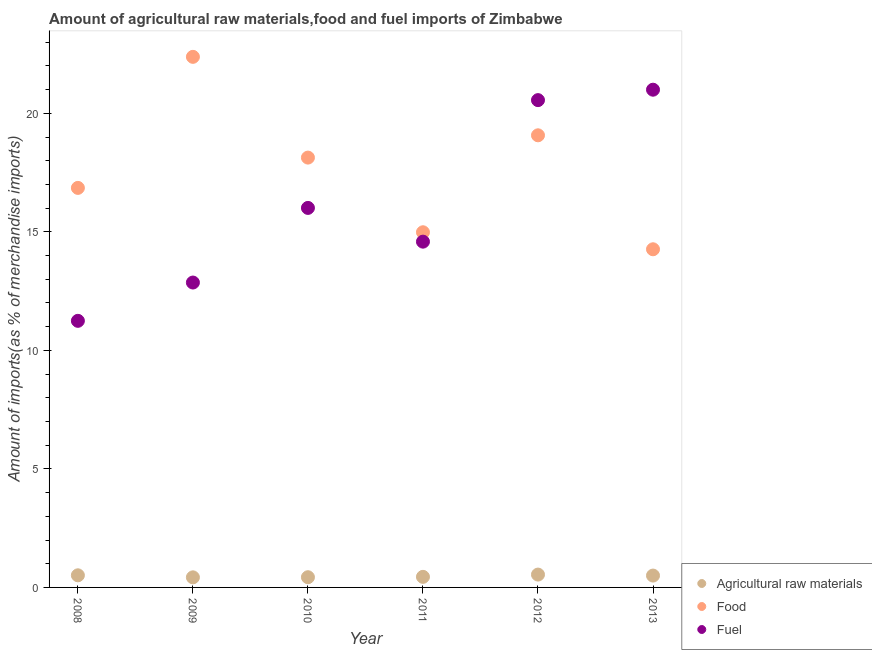How many different coloured dotlines are there?
Your answer should be compact. 3. Is the number of dotlines equal to the number of legend labels?
Ensure brevity in your answer.  Yes. What is the percentage of food imports in 2008?
Your answer should be very brief. 16.85. Across all years, what is the maximum percentage of raw materials imports?
Offer a very short reply. 0.54. Across all years, what is the minimum percentage of raw materials imports?
Provide a succinct answer. 0.43. In which year was the percentage of raw materials imports maximum?
Provide a succinct answer. 2012. In which year was the percentage of food imports minimum?
Your answer should be compact. 2013. What is the total percentage of food imports in the graph?
Provide a short and direct response. 105.69. What is the difference between the percentage of fuel imports in 2008 and that in 2011?
Ensure brevity in your answer.  -3.34. What is the difference between the percentage of fuel imports in 2010 and the percentage of food imports in 2012?
Offer a terse response. -3.06. What is the average percentage of fuel imports per year?
Make the answer very short. 16.04. In the year 2011, what is the difference between the percentage of food imports and percentage of raw materials imports?
Provide a succinct answer. 14.54. In how many years, is the percentage of raw materials imports greater than 3 %?
Offer a terse response. 0. What is the ratio of the percentage of raw materials imports in 2012 to that in 2013?
Make the answer very short. 1.08. What is the difference between the highest and the second highest percentage of fuel imports?
Make the answer very short. 0.44. What is the difference between the highest and the lowest percentage of fuel imports?
Offer a terse response. 9.75. In how many years, is the percentage of raw materials imports greater than the average percentage of raw materials imports taken over all years?
Offer a terse response. 3. Is it the case that in every year, the sum of the percentage of raw materials imports and percentage of food imports is greater than the percentage of fuel imports?
Give a very brief answer. No. Is the percentage of fuel imports strictly less than the percentage of raw materials imports over the years?
Give a very brief answer. No. How many years are there in the graph?
Provide a succinct answer. 6. How many legend labels are there?
Provide a short and direct response. 3. What is the title of the graph?
Offer a very short reply. Amount of agricultural raw materials,food and fuel imports of Zimbabwe. Does "Secondary" appear as one of the legend labels in the graph?
Ensure brevity in your answer.  No. What is the label or title of the Y-axis?
Ensure brevity in your answer.  Amount of imports(as % of merchandise imports). What is the Amount of imports(as % of merchandise imports) of Agricultural raw materials in 2008?
Provide a short and direct response. 0.51. What is the Amount of imports(as % of merchandise imports) in Food in 2008?
Provide a succinct answer. 16.85. What is the Amount of imports(as % of merchandise imports) in Fuel in 2008?
Provide a short and direct response. 11.25. What is the Amount of imports(as % of merchandise imports) of Agricultural raw materials in 2009?
Your response must be concise. 0.43. What is the Amount of imports(as % of merchandise imports) of Food in 2009?
Your response must be concise. 22.38. What is the Amount of imports(as % of merchandise imports) of Fuel in 2009?
Your answer should be compact. 12.86. What is the Amount of imports(as % of merchandise imports) of Agricultural raw materials in 2010?
Provide a short and direct response. 0.43. What is the Amount of imports(as % of merchandise imports) of Food in 2010?
Offer a very short reply. 18.13. What is the Amount of imports(as % of merchandise imports) of Fuel in 2010?
Make the answer very short. 16.01. What is the Amount of imports(as % of merchandise imports) in Agricultural raw materials in 2011?
Provide a short and direct response. 0.45. What is the Amount of imports(as % of merchandise imports) of Food in 2011?
Provide a short and direct response. 14.98. What is the Amount of imports(as % of merchandise imports) in Fuel in 2011?
Provide a short and direct response. 14.59. What is the Amount of imports(as % of merchandise imports) in Agricultural raw materials in 2012?
Provide a succinct answer. 0.54. What is the Amount of imports(as % of merchandise imports) of Food in 2012?
Make the answer very short. 19.07. What is the Amount of imports(as % of merchandise imports) of Fuel in 2012?
Provide a succinct answer. 20.56. What is the Amount of imports(as % of merchandise imports) in Agricultural raw materials in 2013?
Your response must be concise. 0.5. What is the Amount of imports(as % of merchandise imports) in Food in 2013?
Keep it short and to the point. 14.26. What is the Amount of imports(as % of merchandise imports) in Fuel in 2013?
Provide a short and direct response. 21. Across all years, what is the maximum Amount of imports(as % of merchandise imports) in Agricultural raw materials?
Your answer should be compact. 0.54. Across all years, what is the maximum Amount of imports(as % of merchandise imports) of Food?
Provide a short and direct response. 22.38. Across all years, what is the maximum Amount of imports(as % of merchandise imports) of Fuel?
Give a very brief answer. 21. Across all years, what is the minimum Amount of imports(as % of merchandise imports) of Agricultural raw materials?
Provide a short and direct response. 0.43. Across all years, what is the minimum Amount of imports(as % of merchandise imports) in Food?
Provide a succinct answer. 14.26. Across all years, what is the minimum Amount of imports(as % of merchandise imports) in Fuel?
Offer a very short reply. 11.25. What is the total Amount of imports(as % of merchandise imports) in Agricultural raw materials in the graph?
Provide a short and direct response. 2.85. What is the total Amount of imports(as % of merchandise imports) of Food in the graph?
Provide a short and direct response. 105.69. What is the total Amount of imports(as % of merchandise imports) of Fuel in the graph?
Give a very brief answer. 96.26. What is the difference between the Amount of imports(as % of merchandise imports) of Agricultural raw materials in 2008 and that in 2009?
Your answer should be compact. 0.09. What is the difference between the Amount of imports(as % of merchandise imports) of Food in 2008 and that in 2009?
Give a very brief answer. -5.53. What is the difference between the Amount of imports(as % of merchandise imports) of Fuel in 2008 and that in 2009?
Give a very brief answer. -1.62. What is the difference between the Amount of imports(as % of merchandise imports) in Agricultural raw materials in 2008 and that in 2010?
Keep it short and to the point. 0.08. What is the difference between the Amount of imports(as % of merchandise imports) in Food in 2008 and that in 2010?
Provide a succinct answer. -1.28. What is the difference between the Amount of imports(as % of merchandise imports) in Fuel in 2008 and that in 2010?
Keep it short and to the point. -4.76. What is the difference between the Amount of imports(as % of merchandise imports) of Agricultural raw materials in 2008 and that in 2011?
Provide a short and direct response. 0.07. What is the difference between the Amount of imports(as % of merchandise imports) in Food in 2008 and that in 2011?
Ensure brevity in your answer.  1.87. What is the difference between the Amount of imports(as % of merchandise imports) of Fuel in 2008 and that in 2011?
Provide a short and direct response. -3.34. What is the difference between the Amount of imports(as % of merchandise imports) in Agricultural raw materials in 2008 and that in 2012?
Offer a terse response. -0.03. What is the difference between the Amount of imports(as % of merchandise imports) in Food in 2008 and that in 2012?
Provide a short and direct response. -2.22. What is the difference between the Amount of imports(as % of merchandise imports) of Fuel in 2008 and that in 2012?
Provide a short and direct response. -9.31. What is the difference between the Amount of imports(as % of merchandise imports) in Agricultural raw materials in 2008 and that in 2013?
Give a very brief answer. 0.01. What is the difference between the Amount of imports(as % of merchandise imports) in Food in 2008 and that in 2013?
Keep it short and to the point. 2.59. What is the difference between the Amount of imports(as % of merchandise imports) in Fuel in 2008 and that in 2013?
Keep it short and to the point. -9.75. What is the difference between the Amount of imports(as % of merchandise imports) in Agricultural raw materials in 2009 and that in 2010?
Provide a short and direct response. -0.01. What is the difference between the Amount of imports(as % of merchandise imports) of Food in 2009 and that in 2010?
Provide a short and direct response. 4.25. What is the difference between the Amount of imports(as % of merchandise imports) in Fuel in 2009 and that in 2010?
Provide a short and direct response. -3.15. What is the difference between the Amount of imports(as % of merchandise imports) in Agricultural raw materials in 2009 and that in 2011?
Your response must be concise. -0.02. What is the difference between the Amount of imports(as % of merchandise imports) in Food in 2009 and that in 2011?
Make the answer very short. 7.4. What is the difference between the Amount of imports(as % of merchandise imports) in Fuel in 2009 and that in 2011?
Your answer should be compact. -1.72. What is the difference between the Amount of imports(as % of merchandise imports) of Agricultural raw materials in 2009 and that in 2012?
Provide a succinct answer. -0.12. What is the difference between the Amount of imports(as % of merchandise imports) in Food in 2009 and that in 2012?
Your answer should be compact. 3.31. What is the difference between the Amount of imports(as % of merchandise imports) of Fuel in 2009 and that in 2012?
Offer a very short reply. -7.69. What is the difference between the Amount of imports(as % of merchandise imports) of Agricultural raw materials in 2009 and that in 2013?
Provide a short and direct response. -0.07. What is the difference between the Amount of imports(as % of merchandise imports) in Food in 2009 and that in 2013?
Keep it short and to the point. 8.12. What is the difference between the Amount of imports(as % of merchandise imports) of Fuel in 2009 and that in 2013?
Give a very brief answer. -8.13. What is the difference between the Amount of imports(as % of merchandise imports) of Agricultural raw materials in 2010 and that in 2011?
Provide a succinct answer. -0.02. What is the difference between the Amount of imports(as % of merchandise imports) in Food in 2010 and that in 2011?
Keep it short and to the point. 3.15. What is the difference between the Amount of imports(as % of merchandise imports) of Fuel in 2010 and that in 2011?
Provide a short and direct response. 1.42. What is the difference between the Amount of imports(as % of merchandise imports) of Agricultural raw materials in 2010 and that in 2012?
Make the answer very short. -0.11. What is the difference between the Amount of imports(as % of merchandise imports) in Food in 2010 and that in 2012?
Your answer should be very brief. -0.94. What is the difference between the Amount of imports(as % of merchandise imports) in Fuel in 2010 and that in 2012?
Your response must be concise. -4.55. What is the difference between the Amount of imports(as % of merchandise imports) of Agricultural raw materials in 2010 and that in 2013?
Offer a terse response. -0.07. What is the difference between the Amount of imports(as % of merchandise imports) in Food in 2010 and that in 2013?
Ensure brevity in your answer.  3.87. What is the difference between the Amount of imports(as % of merchandise imports) in Fuel in 2010 and that in 2013?
Your response must be concise. -4.99. What is the difference between the Amount of imports(as % of merchandise imports) in Agricultural raw materials in 2011 and that in 2012?
Provide a succinct answer. -0.1. What is the difference between the Amount of imports(as % of merchandise imports) in Food in 2011 and that in 2012?
Provide a short and direct response. -4.09. What is the difference between the Amount of imports(as % of merchandise imports) of Fuel in 2011 and that in 2012?
Provide a succinct answer. -5.97. What is the difference between the Amount of imports(as % of merchandise imports) in Agricultural raw materials in 2011 and that in 2013?
Keep it short and to the point. -0.05. What is the difference between the Amount of imports(as % of merchandise imports) in Food in 2011 and that in 2013?
Provide a succinct answer. 0.72. What is the difference between the Amount of imports(as % of merchandise imports) of Fuel in 2011 and that in 2013?
Your response must be concise. -6.41. What is the difference between the Amount of imports(as % of merchandise imports) in Agricultural raw materials in 2012 and that in 2013?
Ensure brevity in your answer.  0.04. What is the difference between the Amount of imports(as % of merchandise imports) in Food in 2012 and that in 2013?
Provide a succinct answer. 4.81. What is the difference between the Amount of imports(as % of merchandise imports) of Fuel in 2012 and that in 2013?
Provide a short and direct response. -0.44. What is the difference between the Amount of imports(as % of merchandise imports) of Agricultural raw materials in 2008 and the Amount of imports(as % of merchandise imports) of Food in 2009?
Provide a succinct answer. -21.87. What is the difference between the Amount of imports(as % of merchandise imports) in Agricultural raw materials in 2008 and the Amount of imports(as % of merchandise imports) in Fuel in 2009?
Ensure brevity in your answer.  -12.35. What is the difference between the Amount of imports(as % of merchandise imports) in Food in 2008 and the Amount of imports(as % of merchandise imports) in Fuel in 2009?
Your response must be concise. 3.99. What is the difference between the Amount of imports(as % of merchandise imports) in Agricultural raw materials in 2008 and the Amount of imports(as % of merchandise imports) in Food in 2010?
Your response must be concise. -17.62. What is the difference between the Amount of imports(as % of merchandise imports) of Agricultural raw materials in 2008 and the Amount of imports(as % of merchandise imports) of Fuel in 2010?
Offer a very short reply. -15.5. What is the difference between the Amount of imports(as % of merchandise imports) of Food in 2008 and the Amount of imports(as % of merchandise imports) of Fuel in 2010?
Your answer should be compact. 0.84. What is the difference between the Amount of imports(as % of merchandise imports) of Agricultural raw materials in 2008 and the Amount of imports(as % of merchandise imports) of Food in 2011?
Keep it short and to the point. -14.47. What is the difference between the Amount of imports(as % of merchandise imports) in Agricultural raw materials in 2008 and the Amount of imports(as % of merchandise imports) in Fuel in 2011?
Your answer should be very brief. -14.07. What is the difference between the Amount of imports(as % of merchandise imports) of Food in 2008 and the Amount of imports(as % of merchandise imports) of Fuel in 2011?
Give a very brief answer. 2.27. What is the difference between the Amount of imports(as % of merchandise imports) in Agricultural raw materials in 2008 and the Amount of imports(as % of merchandise imports) in Food in 2012?
Make the answer very short. -18.56. What is the difference between the Amount of imports(as % of merchandise imports) of Agricultural raw materials in 2008 and the Amount of imports(as % of merchandise imports) of Fuel in 2012?
Provide a succinct answer. -20.05. What is the difference between the Amount of imports(as % of merchandise imports) in Food in 2008 and the Amount of imports(as % of merchandise imports) in Fuel in 2012?
Your answer should be very brief. -3.7. What is the difference between the Amount of imports(as % of merchandise imports) in Agricultural raw materials in 2008 and the Amount of imports(as % of merchandise imports) in Food in 2013?
Offer a very short reply. -13.75. What is the difference between the Amount of imports(as % of merchandise imports) in Agricultural raw materials in 2008 and the Amount of imports(as % of merchandise imports) in Fuel in 2013?
Provide a short and direct response. -20.48. What is the difference between the Amount of imports(as % of merchandise imports) of Food in 2008 and the Amount of imports(as % of merchandise imports) of Fuel in 2013?
Make the answer very short. -4.14. What is the difference between the Amount of imports(as % of merchandise imports) in Agricultural raw materials in 2009 and the Amount of imports(as % of merchandise imports) in Food in 2010?
Provide a succinct answer. -17.71. What is the difference between the Amount of imports(as % of merchandise imports) in Agricultural raw materials in 2009 and the Amount of imports(as % of merchandise imports) in Fuel in 2010?
Ensure brevity in your answer.  -15.58. What is the difference between the Amount of imports(as % of merchandise imports) in Food in 2009 and the Amount of imports(as % of merchandise imports) in Fuel in 2010?
Make the answer very short. 6.37. What is the difference between the Amount of imports(as % of merchandise imports) in Agricultural raw materials in 2009 and the Amount of imports(as % of merchandise imports) in Food in 2011?
Provide a short and direct response. -14.56. What is the difference between the Amount of imports(as % of merchandise imports) of Agricultural raw materials in 2009 and the Amount of imports(as % of merchandise imports) of Fuel in 2011?
Make the answer very short. -14.16. What is the difference between the Amount of imports(as % of merchandise imports) in Food in 2009 and the Amount of imports(as % of merchandise imports) in Fuel in 2011?
Make the answer very short. 7.8. What is the difference between the Amount of imports(as % of merchandise imports) in Agricultural raw materials in 2009 and the Amount of imports(as % of merchandise imports) in Food in 2012?
Offer a very short reply. -18.65. What is the difference between the Amount of imports(as % of merchandise imports) of Agricultural raw materials in 2009 and the Amount of imports(as % of merchandise imports) of Fuel in 2012?
Keep it short and to the point. -20.13. What is the difference between the Amount of imports(as % of merchandise imports) in Food in 2009 and the Amount of imports(as % of merchandise imports) in Fuel in 2012?
Give a very brief answer. 1.83. What is the difference between the Amount of imports(as % of merchandise imports) in Agricultural raw materials in 2009 and the Amount of imports(as % of merchandise imports) in Food in 2013?
Your answer should be very brief. -13.84. What is the difference between the Amount of imports(as % of merchandise imports) in Agricultural raw materials in 2009 and the Amount of imports(as % of merchandise imports) in Fuel in 2013?
Give a very brief answer. -20.57. What is the difference between the Amount of imports(as % of merchandise imports) in Food in 2009 and the Amount of imports(as % of merchandise imports) in Fuel in 2013?
Provide a short and direct response. 1.39. What is the difference between the Amount of imports(as % of merchandise imports) in Agricultural raw materials in 2010 and the Amount of imports(as % of merchandise imports) in Food in 2011?
Make the answer very short. -14.55. What is the difference between the Amount of imports(as % of merchandise imports) in Agricultural raw materials in 2010 and the Amount of imports(as % of merchandise imports) in Fuel in 2011?
Your response must be concise. -14.16. What is the difference between the Amount of imports(as % of merchandise imports) in Food in 2010 and the Amount of imports(as % of merchandise imports) in Fuel in 2011?
Keep it short and to the point. 3.55. What is the difference between the Amount of imports(as % of merchandise imports) in Agricultural raw materials in 2010 and the Amount of imports(as % of merchandise imports) in Food in 2012?
Ensure brevity in your answer.  -18.64. What is the difference between the Amount of imports(as % of merchandise imports) in Agricultural raw materials in 2010 and the Amount of imports(as % of merchandise imports) in Fuel in 2012?
Provide a succinct answer. -20.13. What is the difference between the Amount of imports(as % of merchandise imports) of Food in 2010 and the Amount of imports(as % of merchandise imports) of Fuel in 2012?
Your answer should be very brief. -2.42. What is the difference between the Amount of imports(as % of merchandise imports) of Agricultural raw materials in 2010 and the Amount of imports(as % of merchandise imports) of Food in 2013?
Make the answer very short. -13.83. What is the difference between the Amount of imports(as % of merchandise imports) of Agricultural raw materials in 2010 and the Amount of imports(as % of merchandise imports) of Fuel in 2013?
Offer a terse response. -20.57. What is the difference between the Amount of imports(as % of merchandise imports) of Food in 2010 and the Amount of imports(as % of merchandise imports) of Fuel in 2013?
Offer a very short reply. -2.86. What is the difference between the Amount of imports(as % of merchandise imports) of Agricultural raw materials in 2011 and the Amount of imports(as % of merchandise imports) of Food in 2012?
Your answer should be compact. -18.63. What is the difference between the Amount of imports(as % of merchandise imports) of Agricultural raw materials in 2011 and the Amount of imports(as % of merchandise imports) of Fuel in 2012?
Your answer should be compact. -20.11. What is the difference between the Amount of imports(as % of merchandise imports) of Food in 2011 and the Amount of imports(as % of merchandise imports) of Fuel in 2012?
Your answer should be compact. -5.57. What is the difference between the Amount of imports(as % of merchandise imports) of Agricultural raw materials in 2011 and the Amount of imports(as % of merchandise imports) of Food in 2013?
Provide a succinct answer. -13.82. What is the difference between the Amount of imports(as % of merchandise imports) in Agricultural raw materials in 2011 and the Amount of imports(as % of merchandise imports) in Fuel in 2013?
Provide a succinct answer. -20.55. What is the difference between the Amount of imports(as % of merchandise imports) in Food in 2011 and the Amount of imports(as % of merchandise imports) in Fuel in 2013?
Your answer should be compact. -6.01. What is the difference between the Amount of imports(as % of merchandise imports) of Agricultural raw materials in 2012 and the Amount of imports(as % of merchandise imports) of Food in 2013?
Your answer should be very brief. -13.72. What is the difference between the Amount of imports(as % of merchandise imports) of Agricultural raw materials in 2012 and the Amount of imports(as % of merchandise imports) of Fuel in 2013?
Your response must be concise. -20.45. What is the difference between the Amount of imports(as % of merchandise imports) of Food in 2012 and the Amount of imports(as % of merchandise imports) of Fuel in 2013?
Your answer should be very brief. -1.92. What is the average Amount of imports(as % of merchandise imports) of Agricultural raw materials per year?
Your answer should be compact. 0.48. What is the average Amount of imports(as % of merchandise imports) in Food per year?
Provide a short and direct response. 17.61. What is the average Amount of imports(as % of merchandise imports) in Fuel per year?
Give a very brief answer. 16.04. In the year 2008, what is the difference between the Amount of imports(as % of merchandise imports) of Agricultural raw materials and Amount of imports(as % of merchandise imports) of Food?
Your answer should be very brief. -16.34. In the year 2008, what is the difference between the Amount of imports(as % of merchandise imports) of Agricultural raw materials and Amount of imports(as % of merchandise imports) of Fuel?
Provide a short and direct response. -10.73. In the year 2008, what is the difference between the Amount of imports(as % of merchandise imports) in Food and Amount of imports(as % of merchandise imports) in Fuel?
Offer a terse response. 5.61. In the year 2009, what is the difference between the Amount of imports(as % of merchandise imports) in Agricultural raw materials and Amount of imports(as % of merchandise imports) in Food?
Provide a succinct answer. -21.96. In the year 2009, what is the difference between the Amount of imports(as % of merchandise imports) in Agricultural raw materials and Amount of imports(as % of merchandise imports) in Fuel?
Your answer should be compact. -12.44. In the year 2009, what is the difference between the Amount of imports(as % of merchandise imports) in Food and Amount of imports(as % of merchandise imports) in Fuel?
Provide a succinct answer. 9.52. In the year 2010, what is the difference between the Amount of imports(as % of merchandise imports) of Agricultural raw materials and Amount of imports(as % of merchandise imports) of Food?
Your answer should be very brief. -17.7. In the year 2010, what is the difference between the Amount of imports(as % of merchandise imports) in Agricultural raw materials and Amount of imports(as % of merchandise imports) in Fuel?
Your response must be concise. -15.58. In the year 2010, what is the difference between the Amount of imports(as % of merchandise imports) of Food and Amount of imports(as % of merchandise imports) of Fuel?
Your answer should be very brief. 2.12. In the year 2011, what is the difference between the Amount of imports(as % of merchandise imports) of Agricultural raw materials and Amount of imports(as % of merchandise imports) of Food?
Ensure brevity in your answer.  -14.54. In the year 2011, what is the difference between the Amount of imports(as % of merchandise imports) in Agricultural raw materials and Amount of imports(as % of merchandise imports) in Fuel?
Provide a short and direct response. -14.14. In the year 2011, what is the difference between the Amount of imports(as % of merchandise imports) of Food and Amount of imports(as % of merchandise imports) of Fuel?
Ensure brevity in your answer.  0.4. In the year 2012, what is the difference between the Amount of imports(as % of merchandise imports) of Agricultural raw materials and Amount of imports(as % of merchandise imports) of Food?
Provide a succinct answer. -18.53. In the year 2012, what is the difference between the Amount of imports(as % of merchandise imports) of Agricultural raw materials and Amount of imports(as % of merchandise imports) of Fuel?
Give a very brief answer. -20.01. In the year 2012, what is the difference between the Amount of imports(as % of merchandise imports) of Food and Amount of imports(as % of merchandise imports) of Fuel?
Provide a short and direct response. -1.48. In the year 2013, what is the difference between the Amount of imports(as % of merchandise imports) of Agricultural raw materials and Amount of imports(as % of merchandise imports) of Food?
Your answer should be very brief. -13.76. In the year 2013, what is the difference between the Amount of imports(as % of merchandise imports) in Agricultural raw materials and Amount of imports(as % of merchandise imports) in Fuel?
Your response must be concise. -20.5. In the year 2013, what is the difference between the Amount of imports(as % of merchandise imports) in Food and Amount of imports(as % of merchandise imports) in Fuel?
Keep it short and to the point. -6.73. What is the ratio of the Amount of imports(as % of merchandise imports) of Agricultural raw materials in 2008 to that in 2009?
Your answer should be very brief. 1.2. What is the ratio of the Amount of imports(as % of merchandise imports) of Food in 2008 to that in 2009?
Your answer should be very brief. 0.75. What is the ratio of the Amount of imports(as % of merchandise imports) in Fuel in 2008 to that in 2009?
Provide a short and direct response. 0.87. What is the ratio of the Amount of imports(as % of merchandise imports) in Agricultural raw materials in 2008 to that in 2010?
Provide a short and direct response. 1.19. What is the ratio of the Amount of imports(as % of merchandise imports) of Food in 2008 to that in 2010?
Offer a terse response. 0.93. What is the ratio of the Amount of imports(as % of merchandise imports) in Fuel in 2008 to that in 2010?
Your answer should be compact. 0.7. What is the ratio of the Amount of imports(as % of merchandise imports) of Agricultural raw materials in 2008 to that in 2011?
Your response must be concise. 1.15. What is the ratio of the Amount of imports(as % of merchandise imports) of Food in 2008 to that in 2011?
Offer a terse response. 1.12. What is the ratio of the Amount of imports(as % of merchandise imports) of Fuel in 2008 to that in 2011?
Offer a terse response. 0.77. What is the ratio of the Amount of imports(as % of merchandise imports) in Agricultural raw materials in 2008 to that in 2012?
Keep it short and to the point. 0.94. What is the ratio of the Amount of imports(as % of merchandise imports) in Food in 2008 to that in 2012?
Your response must be concise. 0.88. What is the ratio of the Amount of imports(as % of merchandise imports) of Fuel in 2008 to that in 2012?
Offer a terse response. 0.55. What is the ratio of the Amount of imports(as % of merchandise imports) in Food in 2008 to that in 2013?
Your answer should be very brief. 1.18. What is the ratio of the Amount of imports(as % of merchandise imports) in Fuel in 2008 to that in 2013?
Offer a very short reply. 0.54. What is the ratio of the Amount of imports(as % of merchandise imports) in Agricultural raw materials in 2009 to that in 2010?
Your response must be concise. 0.99. What is the ratio of the Amount of imports(as % of merchandise imports) in Food in 2009 to that in 2010?
Offer a terse response. 1.23. What is the ratio of the Amount of imports(as % of merchandise imports) of Fuel in 2009 to that in 2010?
Your response must be concise. 0.8. What is the ratio of the Amount of imports(as % of merchandise imports) of Agricultural raw materials in 2009 to that in 2011?
Provide a succinct answer. 0.95. What is the ratio of the Amount of imports(as % of merchandise imports) in Food in 2009 to that in 2011?
Offer a very short reply. 1.49. What is the ratio of the Amount of imports(as % of merchandise imports) in Fuel in 2009 to that in 2011?
Keep it short and to the point. 0.88. What is the ratio of the Amount of imports(as % of merchandise imports) of Agricultural raw materials in 2009 to that in 2012?
Provide a succinct answer. 0.79. What is the ratio of the Amount of imports(as % of merchandise imports) in Food in 2009 to that in 2012?
Keep it short and to the point. 1.17. What is the ratio of the Amount of imports(as % of merchandise imports) in Fuel in 2009 to that in 2012?
Make the answer very short. 0.63. What is the ratio of the Amount of imports(as % of merchandise imports) in Agricultural raw materials in 2009 to that in 2013?
Provide a short and direct response. 0.85. What is the ratio of the Amount of imports(as % of merchandise imports) in Food in 2009 to that in 2013?
Keep it short and to the point. 1.57. What is the ratio of the Amount of imports(as % of merchandise imports) in Fuel in 2009 to that in 2013?
Offer a terse response. 0.61. What is the ratio of the Amount of imports(as % of merchandise imports) in Agricultural raw materials in 2010 to that in 2011?
Provide a short and direct response. 0.97. What is the ratio of the Amount of imports(as % of merchandise imports) in Food in 2010 to that in 2011?
Give a very brief answer. 1.21. What is the ratio of the Amount of imports(as % of merchandise imports) in Fuel in 2010 to that in 2011?
Provide a short and direct response. 1.1. What is the ratio of the Amount of imports(as % of merchandise imports) of Agricultural raw materials in 2010 to that in 2012?
Provide a short and direct response. 0.79. What is the ratio of the Amount of imports(as % of merchandise imports) of Food in 2010 to that in 2012?
Offer a terse response. 0.95. What is the ratio of the Amount of imports(as % of merchandise imports) of Fuel in 2010 to that in 2012?
Offer a terse response. 0.78. What is the ratio of the Amount of imports(as % of merchandise imports) in Agricultural raw materials in 2010 to that in 2013?
Ensure brevity in your answer.  0.86. What is the ratio of the Amount of imports(as % of merchandise imports) in Food in 2010 to that in 2013?
Ensure brevity in your answer.  1.27. What is the ratio of the Amount of imports(as % of merchandise imports) of Fuel in 2010 to that in 2013?
Offer a very short reply. 0.76. What is the ratio of the Amount of imports(as % of merchandise imports) of Agricultural raw materials in 2011 to that in 2012?
Ensure brevity in your answer.  0.82. What is the ratio of the Amount of imports(as % of merchandise imports) in Food in 2011 to that in 2012?
Your answer should be compact. 0.79. What is the ratio of the Amount of imports(as % of merchandise imports) in Fuel in 2011 to that in 2012?
Offer a terse response. 0.71. What is the ratio of the Amount of imports(as % of merchandise imports) in Agricultural raw materials in 2011 to that in 2013?
Keep it short and to the point. 0.89. What is the ratio of the Amount of imports(as % of merchandise imports) of Food in 2011 to that in 2013?
Give a very brief answer. 1.05. What is the ratio of the Amount of imports(as % of merchandise imports) in Fuel in 2011 to that in 2013?
Provide a succinct answer. 0.69. What is the ratio of the Amount of imports(as % of merchandise imports) in Agricultural raw materials in 2012 to that in 2013?
Your answer should be compact. 1.08. What is the ratio of the Amount of imports(as % of merchandise imports) of Food in 2012 to that in 2013?
Offer a terse response. 1.34. What is the ratio of the Amount of imports(as % of merchandise imports) of Fuel in 2012 to that in 2013?
Your answer should be very brief. 0.98. What is the difference between the highest and the second highest Amount of imports(as % of merchandise imports) in Agricultural raw materials?
Keep it short and to the point. 0.03. What is the difference between the highest and the second highest Amount of imports(as % of merchandise imports) of Food?
Keep it short and to the point. 3.31. What is the difference between the highest and the second highest Amount of imports(as % of merchandise imports) of Fuel?
Offer a terse response. 0.44. What is the difference between the highest and the lowest Amount of imports(as % of merchandise imports) in Agricultural raw materials?
Provide a short and direct response. 0.12. What is the difference between the highest and the lowest Amount of imports(as % of merchandise imports) of Food?
Give a very brief answer. 8.12. What is the difference between the highest and the lowest Amount of imports(as % of merchandise imports) of Fuel?
Your response must be concise. 9.75. 